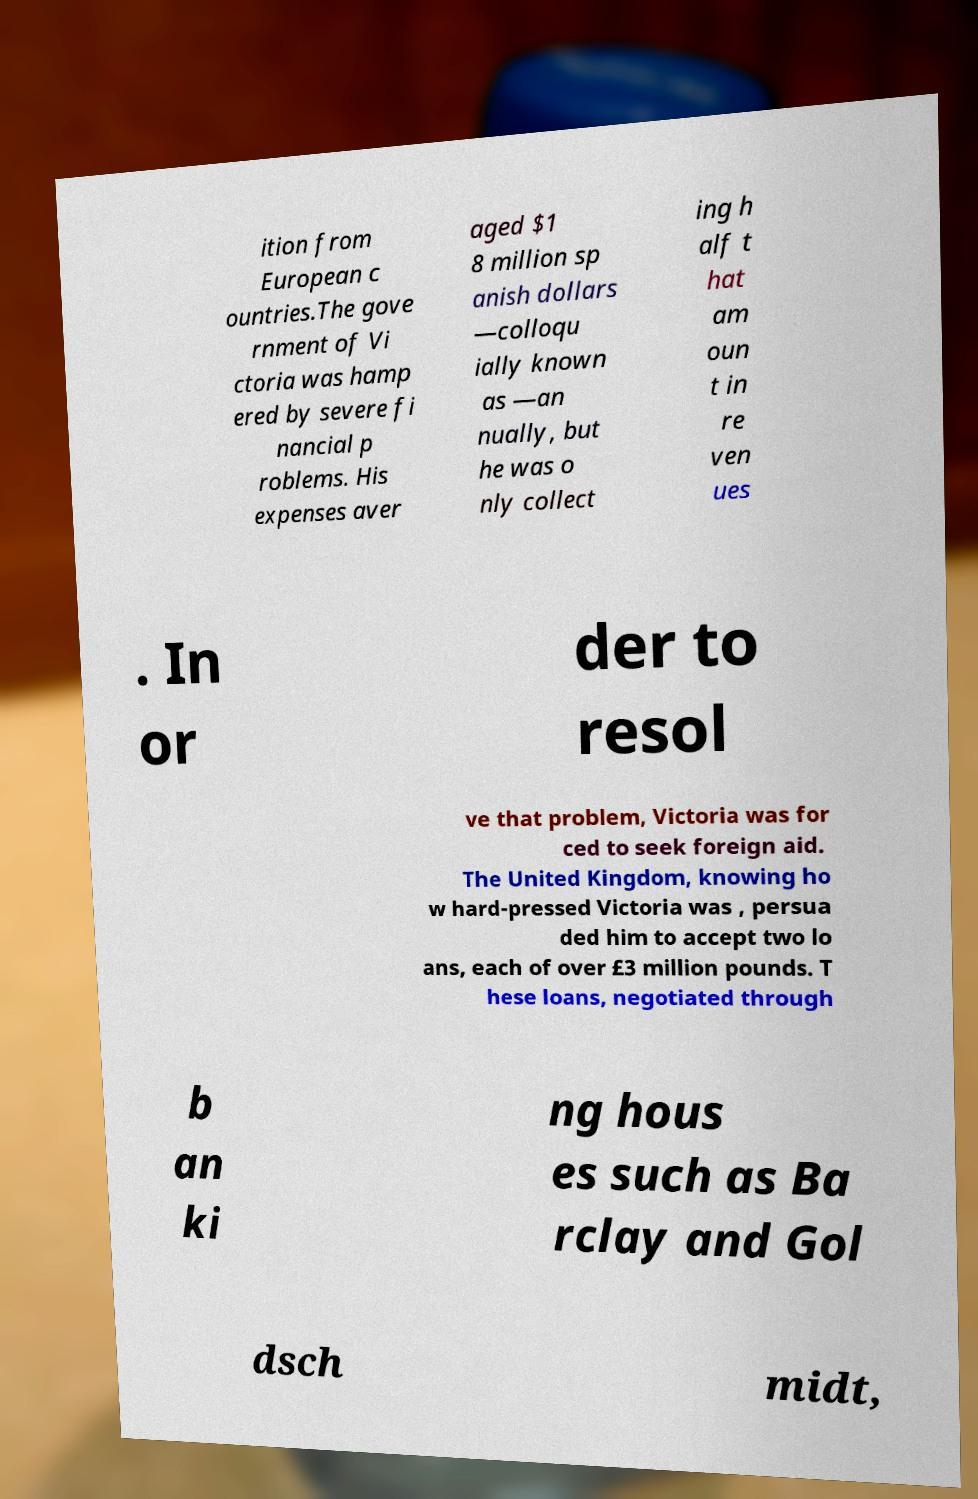Can you accurately transcribe the text from the provided image for me? ition from European c ountries.The gove rnment of Vi ctoria was hamp ered by severe fi nancial p roblems. His expenses aver aged $1 8 million sp anish dollars —colloqu ially known as —an nually, but he was o nly collect ing h alf t hat am oun t in re ven ues . In or der to resol ve that problem, Victoria was for ced to seek foreign aid. The United Kingdom, knowing ho w hard-pressed Victoria was , persua ded him to accept two lo ans, each of over £3 million pounds. T hese loans, negotiated through b an ki ng hous es such as Ba rclay and Gol dsch midt, 